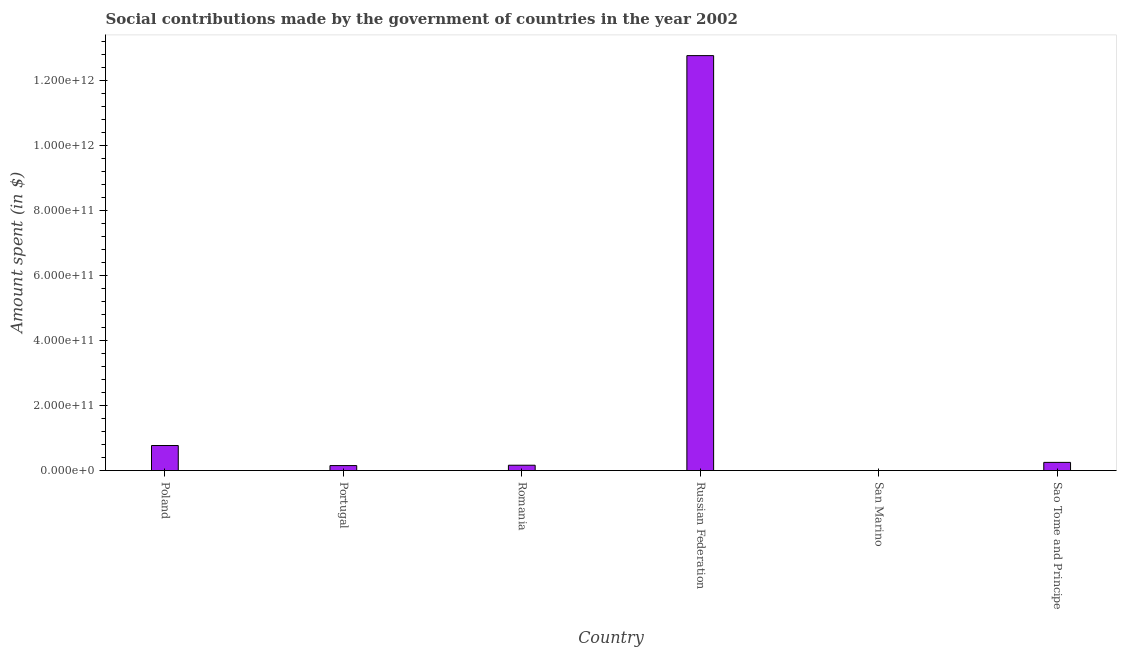Does the graph contain any zero values?
Ensure brevity in your answer.  No. Does the graph contain grids?
Provide a short and direct response. No. What is the title of the graph?
Give a very brief answer. Social contributions made by the government of countries in the year 2002. What is the label or title of the Y-axis?
Your answer should be very brief. Amount spent (in $). What is the amount spent in making social contributions in Romania?
Ensure brevity in your answer.  1.64e+1. Across all countries, what is the maximum amount spent in making social contributions?
Offer a very short reply. 1.28e+12. Across all countries, what is the minimum amount spent in making social contributions?
Offer a very short reply. 9.44e+07. In which country was the amount spent in making social contributions maximum?
Your answer should be compact. Russian Federation. In which country was the amount spent in making social contributions minimum?
Your answer should be compact. San Marino. What is the sum of the amount spent in making social contributions?
Provide a succinct answer. 1.41e+12. What is the difference between the amount spent in making social contributions in San Marino and Sao Tome and Principe?
Ensure brevity in your answer.  -2.51e+1. What is the average amount spent in making social contributions per country?
Make the answer very short. 2.35e+11. What is the median amount spent in making social contributions?
Provide a succinct answer. 2.08e+1. What is the ratio of the amount spent in making social contributions in Romania to that in Sao Tome and Principe?
Your answer should be very brief. 0.65. Is the amount spent in making social contributions in Portugal less than that in San Marino?
Your response must be concise. No. Is the difference between the amount spent in making social contributions in Portugal and Romania greater than the difference between any two countries?
Your response must be concise. No. What is the difference between the highest and the second highest amount spent in making social contributions?
Offer a very short reply. 1.20e+12. What is the difference between the highest and the lowest amount spent in making social contributions?
Ensure brevity in your answer.  1.28e+12. How many bars are there?
Offer a terse response. 6. Are all the bars in the graph horizontal?
Provide a succinct answer. No. How many countries are there in the graph?
Give a very brief answer. 6. What is the difference between two consecutive major ticks on the Y-axis?
Provide a short and direct response. 2.00e+11. What is the Amount spent (in $) in Poland?
Provide a succinct answer. 7.70e+1. What is the Amount spent (in $) of Portugal?
Provide a succinct answer. 1.54e+1. What is the Amount spent (in $) of Romania?
Provide a succinct answer. 1.64e+1. What is the Amount spent (in $) in Russian Federation?
Ensure brevity in your answer.  1.28e+12. What is the Amount spent (in $) of San Marino?
Make the answer very short. 9.44e+07. What is the Amount spent (in $) of Sao Tome and Principe?
Your answer should be compact. 2.52e+1. What is the difference between the Amount spent (in $) in Poland and Portugal?
Your answer should be compact. 6.16e+1. What is the difference between the Amount spent (in $) in Poland and Romania?
Offer a very short reply. 6.06e+1. What is the difference between the Amount spent (in $) in Poland and Russian Federation?
Offer a very short reply. -1.20e+12. What is the difference between the Amount spent (in $) in Poland and San Marino?
Your answer should be very brief. 7.69e+1. What is the difference between the Amount spent (in $) in Poland and Sao Tome and Principe?
Your answer should be very brief. 5.18e+1. What is the difference between the Amount spent (in $) in Portugal and Romania?
Your response must be concise. -1.07e+09. What is the difference between the Amount spent (in $) in Portugal and Russian Federation?
Give a very brief answer. -1.26e+12. What is the difference between the Amount spent (in $) in Portugal and San Marino?
Provide a succinct answer. 1.53e+1. What is the difference between the Amount spent (in $) in Portugal and Sao Tome and Principe?
Give a very brief answer. -9.85e+09. What is the difference between the Amount spent (in $) in Romania and Russian Federation?
Provide a short and direct response. -1.26e+12. What is the difference between the Amount spent (in $) in Romania and San Marino?
Your answer should be very brief. 1.63e+1. What is the difference between the Amount spent (in $) in Romania and Sao Tome and Principe?
Provide a short and direct response. -8.78e+09. What is the difference between the Amount spent (in $) in Russian Federation and San Marino?
Offer a terse response. 1.28e+12. What is the difference between the Amount spent (in $) in Russian Federation and Sao Tome and Principe?
Provide a succinct answer. 1.25e+12. What is the difference between the Amount spent (in $) in San Marino and Sao Tome and Principe?
Ensure brevity in your answer.  -2.51e+1. What is the ratio of the Amount spent (in $) in Poland to that in Portugal?
Your response must be concise. 5.01. What is the ratio of the Amount spent (in $) in Poland to that in Romania?
Keep it short and to the point. 4.69. What is the ratio of the Amount spent (in $) in Poland to that in San Marino?
Your answer should be very brief. 815.98. What is the ratio of the Amount spent (in $) in Poland to that in Sao Tome and Principe?
Give a very brief answer. 3.06. What is the ratio of the Amount spent (in $) in Portugal to that in Romania?
Your answer should be compact. 0.94. What is the ratio of the Amount spent (in $) in Portugal to that in Russian Federation?
Make the answer very short. 0.01. What is the ratio of the Amount spent (in $) in Portugal to that in San Marino?
Give a very brief answer. 162.76. What is the ratio of the Amount spent (in $) in Portugal to that in Sao Tome and Principe?
Make the answer very short. 0.61. What is the ratio of the Amount spent (in $) in Romania to that in Russian Federation?
Your answer should be compact. 0.01. What is the ratio of the Amount spent (in $) in Romania to that in San Marino?
Keep it short and to the point. 174.12. What is the ratio of the Amount spent (in $) in Romania to that in Sao Tome and Principe?
Offer a terse response. 0.65. What is the ratio of the Amount spent (in $) in Russian Federation to that in San Marino?
Give a very brief answer. 1.35e+04. What is the ratio of the Amount spent (in $) in Russian Federation to that in Sao Tome and Principe?
Your answer should be compact. 50.6. What is the ratio of the Amount spent (in $) in San Marino to that in Sao Tome and Principe?
Your answer should be very brief. 0. 